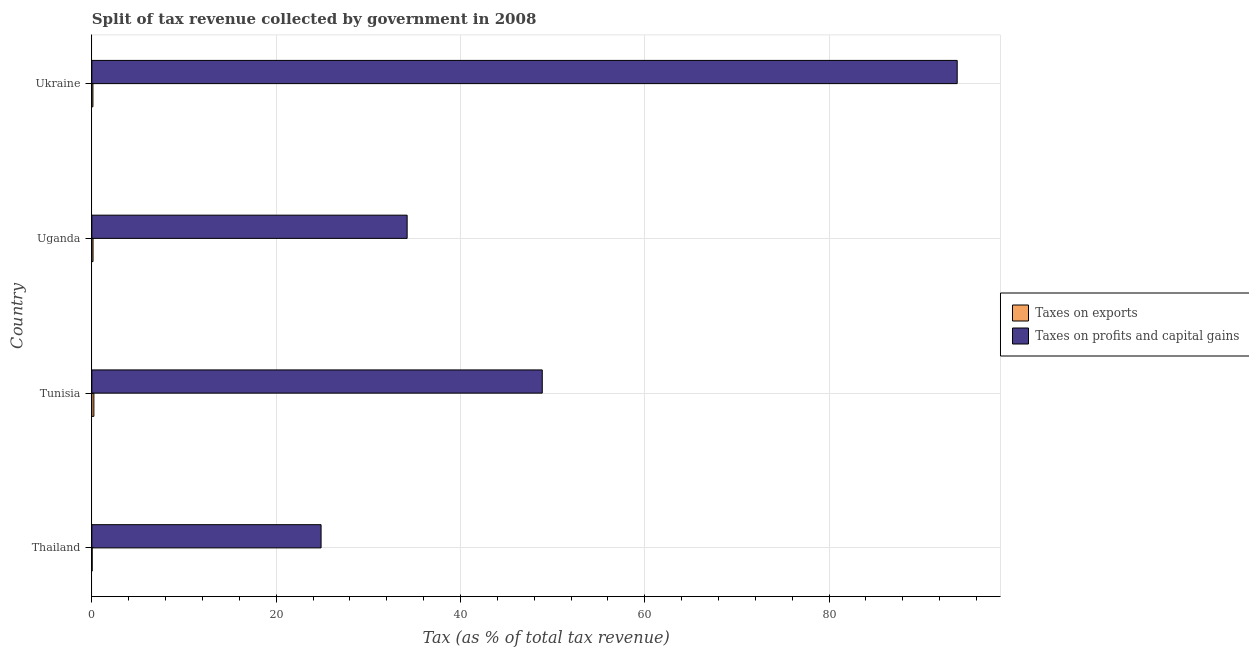How many different coloured bars are there?
Offer a very short reply. 2. How many groups of bars are there?
Your answer should be compact. 4. Are the number of bars per tick equal to the number of legend labels?
Provide a short and direct response. Yes. How many bars are there on the 2nd tick from the bottom?
Ensure brevity in your answer.  2. What is the label of the 2nd group of bars from the top?
Offer a terse response. Uganda. In how many cases, is the number of bars for a given country not equal to the number of legend labels?
Offer a very short reply. 0. What is the percentage of revenue obtained from taxes on exports in Uganda?
Your answer should be very brief. 0.13. Across all countries, what is the maximum percentage of revenue obtained from taxes on exports?
Your answer should be compact. 0.22. Across all countries, what is the minimum percentage of revenue obtained from taxes on exports?
Offer a terse response. 0.03. In which country was the percentage of revenue obtained from taxes on profits and capital gains maximum?
Your response must be concise. Ukraine. In which country was the percentage of revenue obtained from taxes on exports minimum?
Offer a terse response. Thailand. What is the total percentage of revenue obtained from taxes on exports in the graph?
Offer a very short reply. 0.5. What is the difference between the percentage of revenue obtained from taxes on exports in Tunisia and that in Uganda?
Your response must be concise. 0.09. What is the difference between the percentage of revenue obtained from taxes on profits and capital gains in Thailand and the percentage of revenue obtained from taxes on exports in Uganda?
Offer a terse response. 24.75. What is the average percentage of revenue obtained from taxes on exports per country?
Offer a terse response. 0.12. What is the difference between the percentage of revenue obtained from taxes on profits and capital gains and percentage of revenue obtained from taxes on exports in Uganda?
Offer a very short reply. 34.09. What is the ratio of the percentage of revenue obtained from taxes on profits and capital gains in Tunisia to that in Uganda?
Provide a succinct answer. 1.43. Is the percentage of revenue obtained from taxes on profits and capital gains in Tunisia less than that in Ukraine?
Ensure brevity in your answer.  Yes. Is the difference between the percentage of revenue obtained from taxes on exports in Uganda and Ukraine greater than the difference between the percentage of revenue obtained from taxes on profits and capital gains in Uganda and Ukraine?
Give a very brief answer. Yes. What is the difference between the highest and the second highest percentage of revenue obtained from taxes on exports?
Keep it short and to the point. 0.09. What is the difference between the highest and the lowest percentage of revenue obtained from taxes on profits and capital gains?
Provide a short and direct response. 69.03. In how many countries, is the percentage of revenue obtained from taxes on profits and capital gains greater than the average percentage of revenue obtained from taxes on profits and capital gains taken over all countries?
Your response must be concise. 1. Is the sum of the percentage of revenue obtained from taxes on exports in Tunisia and Uganda greater than the maximum percentage of revenue obtained from taxes on profits and capital gains across all countries?
Your answer should be very brief. No. What does the 1st bar from the top in Thailand represents?
Provide a succinct answer. Taxes on profits and capital gains. What does the 1st bar from the bottom in Thailand represents?
Your answer should be compact. Taxes on exports. Are all the bars in the graph horizontal?
Your response must be concise. Yes. How many countries are there in the graph?
Provide a succinct answer. 4. Does the graph contain any zero values?
Provide a succinct answer. No. Does the graph contain grids?
Your answer should be compact. Yes. How many legend labels are there?
Offer a very short reply. 2. How are the legend labels stacked?
Offer a terse response. Vertical. What is the title of the graph?
Provide a succinct answer. Split of tax revenue collected by government in 2008. What is the label or title of the X-axis?
Give a very brief answer. Tax (as % of total tax revenue). What is the Tax (as % of total tax revenue) of Taxes on exports in Thailand?
Ensure brevity in your answer.  0.03. What is the Tax (as % of total tax revenue) in Taxes on profits and capital gains in Thailand?
Your answer should be compact. 24.88. What is the Tax (as % of total tax revenue) of Taxes on exports in Tunisia?
Keep it short and to the point. 0.22. What is the Tax (as % of total tax revenue) in Taxes on profits and capital gains in Tunisia?
Keep it short and to the point. 48.88. What is the Tax (as % of total tax revenue) of Taxes on exports in Uganda?
Your answer should be very brief. 0.13. What is the Tax (as % of total tax revenue) of Taxes on profits and capital gains in Uganda?
Your response must be concise. 34.21. What is the Tax (as % of total tax revenue) of Taxes on exports in Ukraine?
Your answer should be compact. 0.12. What is the Tax (as % of total tax revenue) in Taxes on profits and capital gains in Ukraine?
Keep it short and to the point. 93.9. Across all countries, what is the maximum Tax (as % of total tax revenue) of Taxes on exports?
Give a very brief answer. 0.22. Across all countries, what is the maximum Tax (as % of total tax revenue) in Taxes on profits and capital gains?
Offer a very short reply. 93.9. Across all countries, what is the minimum Tax (as % of total tax revenue) in Taxes on exports?
Your answer should be very brief. 0.03. Across all countries, what is the minimum Tax (as % of total tax revenue) of Taxes on profits and capital gains?
Provide a succinct answer. 24.88. What is the total Tax (as % of total tax revenue) of Taxes on exports in the graph?
Make the answer very short. 0.5. What is the total Tax (as % of total tax revenue) in Taxes on profits and capital gains in the graph?
Ensure brevity in your answer.  201.87. What is the difference between the Tax (as % of total tax revenue) in Taxes on exports in Thailand and that in Tunisia?
Provide a short and direct response. -0.19. What is the difference between the Tax (as % of total tax revenue) of Taxes on profits and capital gains in Thailand and that in Tunisia?
Make the answer very short. -24. What is the difference between the Tax (as % of total tax revenue) in Taxes on exports in Thailand and that in Uganda?
Offer a very short reply. -0.1. What is the difference between the Tax (as % of total tax revenue) of Taxes on profits and capital gains in Thailand and that in Uganda?
Your answer should be very brief. -9.34. What is the difference between the Tax (as % of total tax revenue) in Taxes on exports in Thailand and that in Ukraine?
Give a very brief answer. -0.08. What is the difference between the Tax (as % of total tax revenue) of Taxes on profits and capital gains in Thailand and that in Ukraine?
Your response must be concise. -69.03. What is the difference between the Tax (as % of total tax revenue) in Taxes on exports in Tunisia and that in Uganda?
Your answer should be compact. 0.09. What is the difference between the Tax (as % of total tax revenue) in Taxes on profits and capital gains in Tunisia and that in Uganda?
Ensure brevity in your answer.  14.66. What is the difference between the Tax (as % of total tax revenue) in Taxes on exports in Tunisia and that in Ukraine?
Provide a short and direct response. 0.1. What is the difference between the Tax (as % of total tax revenue) in Taxes on profits and capital gains in Tunisia and that in Ukraine?
Give a very brief answer. -45.03. What is the difference between the Tax (as % of total tax revenue) in Taxes on exports in Uganda and that in Ukraine?
Offer a very short reply. 0.01. What is the difference between the Tax (as % of total tax revenue) of Taxes on profits and capital gains in Uganda and that in Ukraine?
Your answer should be very brief. -59.69. What is the difference between the Tax (as % of total tax revenue) of Taxes on exports in Thailand and the Tax (as % of total tax revenue) of Taxes on profits and capital gains in Tunisia?
Give a very brief answer. -48.84. What is the difference between the Tax (as % of total tax revenue) in Taxes on exports in Thailand and the Tax (as % of total tax revenue) in Taxes on profits and capital gains in Uganda?
Give a very brief answer. -34.18. What is the difference between the Tax (as % of total tax revenue) in Taxes on exports in Thailand and the Tax (as % of total tax revenue) in Taxes on profits and capital gains in Ukraine?
Provide a short and direct response. -93.87. What is the difference between the Tax (as % of total tax revenue) in Taxes on exports in Tunisia and the Tax (as % of total tax revenue) in Taxes on profits and capital gains in Uganda?
Keep it short and to the point. -33.99. What is the difference between the Tax (as % of total tax revenue) in Taxes on exports in Tunisia and the Tax (as % of total tax revenue) in Taxes on profits and capital gains in Ukraine?
Offer a very short reply. -93.68. What is the difference between the Tax (as % of total tax revenue) of Taxes on exports in Uganda and the Tax (as % of total tax revenue) of Taxes on profits and capital gains in Ukraine?
Your answer should be very brief. -93.78. What is the average Tax (as % of total tax revenue) in Taxes on exports per country?
Ensure brevity in your answer.  0.13. What is the average Tax (as % of total tax revenue) of Taxes on profits and capital gains per country?
Make the answer very short. 50.47. What is the difference between the Tax (as % of total tax revenue) of Taxes on exports and Tax (as % of total tax revenue) of Taxes on profits and capital gains in Thailand?
Make the answer very short. -24.84. What is the difference between the Tax (as % of total tax revenue) in Taxes on exports and Tax (as % of total tax revenue) in Taxes on profits and capital gains in Tunisia?
Your answer should be compact. -48.66. What is the difference between the Tax (as % of total tax revenue) in Taxes on exports and Tax (as % of total tax revenue) in Taxes on profits and capital gains in Uganda?
Give a very brief answer. -34.09. What is the difference between the Tax (as % of total tax revenue) of Taxes on exports and Tax (as % of total tax revenue) of Taxes on profits and capital gains in Ukraine?
Make the answer very short. -93.79. What is the ratio of the Tax (as % of total tax revenue) of Taxes on exports in Thailand to that in Tunisia?
Your response must be concise. 0.15. What is the ratio of the Tax (as % of total tax revenue) in Taxes on profits and capital gains in Thailand to that in Tunisia?
Your answer should be compact. 0.51. What is the ratio of the Tax (as % of total tax revenue) in Taxes on exports in Thailand to that in Uganda?
Make the answer very short. 0.26. What is the ratio of the Tax (as % of total tax revenue) in Taxes on profits and capital gains in Thailand to that in Uganda?
Your response must be concise. 0.73. What is the ratio of the Tax (as % of total tax revenue) of Taxes on exports in Thailand to that in Ukraine?
Your answer should be very brief. 0.29. What is the ratio of the Tax (as % of total tax revenue) in Taxes on profits and capital gains in Thailand to that in Ukraine?
Your response must be concise. 0.26. What is the ratio of the Tax (as % of total tax revenue) in Taxes on exports in Tunisia to that in Uganda?
Offer a very short reply. 1.72. What is the ratio of the Tax (as % of total tax revenue) in Taxes on profits and capital gains in Tunisia to that in Uganda?
Give a very brief answer. 1.43. What is the ratio of the Tax (as % of total tax revenue) of Taxes on exports in Tunisia to that in Ukraine?
Your response must be concise. 1.9. What is the ratio of the Tax (as % of total tax revenue) of Taxes on profits and capital gains in Tunisia to that in Ukraine?
Your answer should be very brief. 0.52. What is the ratio of the Tax (as % of total tax revenue) of Taxes on exports in Uganda to that in Ukraine?
Your response must be concise. 1.11. What is the ratio of the Tax (as % of total tax revenue) in Taxes on profits and capital gains in Uganda to that in Ukraine?
Ensure brevity in your answer.  0.36. What is the difference between the highest and the second highest Tax (as % of total tax revenue) in Taxes on exports?
Give a very brief answer. 0.09. What is the difference between the highest and the second highest Tax (as % of total tax revenue) of Taxes on profits and capital gains?
Your answer should be compact. 45.03. What is the difference between the highest and the lowest Tax (as % of total tax revenue) in Taxes on exports?
Ensure brevity in your answer.  0.19. What is the difference between the highest and the lowest Tax (as % of total tax revenue) of Taxes on profits and capital gains?
Ensure brevity in your answer.  69.03. 